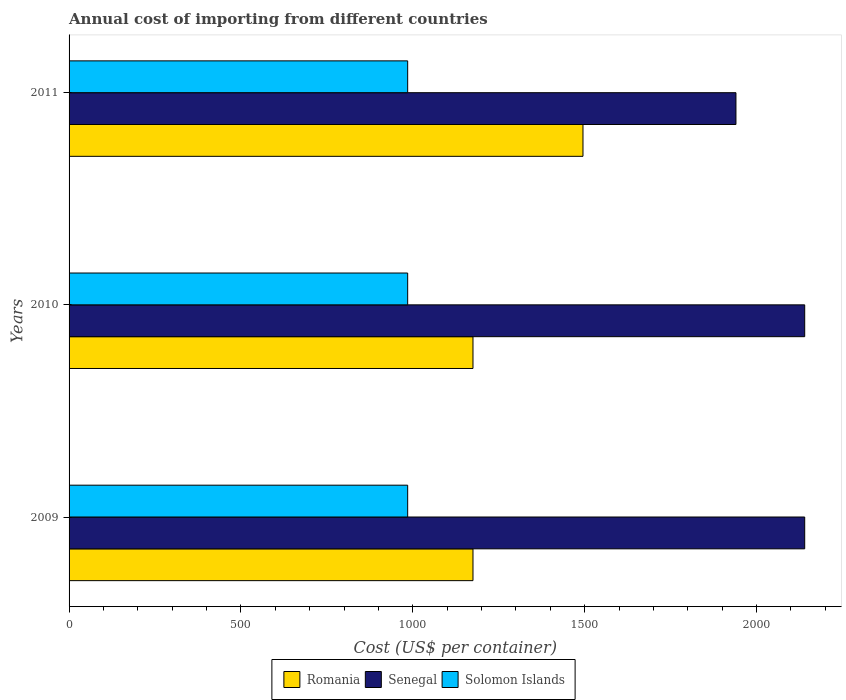How many different coloured bars are there?
Offer a very short reply. 3. Are the number of bars per tick equal to the number of legend labels?
Provide a succinct answer. Yes. How many bars are there on the 1st tick from the top?
Your answer should be very brief. 3. What is the label of the 3rd group of bars from the top?
Provide a short and direct response. 2009. In how many cases, is the number of bars for a given year not equal to the number of legend labels?
Make the answer very short. 0. What is the total annual cost of importing in Solomon Islands in 2009?
Provide a succinct answer. 985. Across all years, what is the maximum total annual cost of importing in Romania?
Your answer should be compact. 1495. Across all years, what is the minimum total annual cost of importing in Solomon Islands?
Your answer should be very brief. 985. In which year was the total annual cost of importing in Senegal maximum?
Ensure brevity in your answer.  2009. In which year was the total annual cost of importing in Romania minimum?
Your answer should be compact. 2009. What is the total total annual cost of importing in Romania in the graph?
Offer a terse response. 3845. What is the difference between the total annual cost of importing in Solomon Islands in 2010 and that in 2011?
Your answer should be compact. 0. What is the difference between the total annual cost of importing in Senegal in 2010 and the total annual cost of importing in Romania in 2009?
Your answer should be very brief. 965. What is the average total annual cost of importing in Romania per year?
Your answer should be compact. 1281.67. In the year 2009, what is the difference between the total annual cost of importing in Senegal and total annual cost of importing in Romania?
Provide a succinct answer. 965. In how many years, is the total annual cost of importing in Solomon Islands greater than 1800 US$?
Offer a very short reply. 0. Is the sum of the total annual cost of importing in Senegal in 2009 and 2011 greater than the maximum total annual cost of importing in Solomon Islands across all years?
Your answer should be compact. Yes. What does the 1st bar from the top in 2009 represents?
Offer a very short reply. Solomon Islands. What does the 2nd bar from the bottom in 2010 represents?
Ensure brevity in your answer.  Senegal. Is it the case that in every year, the sum of the total annual cost of importing in Solomon Islands and total annual cost of importing in Romania is greater than the total annual cost of importing in Senegal?
Provide a succinct answer. Yes. Are all the bars in the graph horizontal?
Ensure brevity in your answer.  Yes. How many years are there in the graph?
Your answer should be compact. 3. What is the difference between two consecutive major ticks on the X-axis?
Your answer should be compact. 500. Does the graph contain any zero values?
Your response must be concise. No. Where does the legend appear in the graph?
Your response must be concise. Bottom center. How many legend labels are there?
Keep it short and to the point. 3. How are the legend labels stacked?
Your answer should be very brief. Horizontal. What is the title of the graph?
Give a very brief answer. Annual cost of importing from different countries. What is the label or title of the X-axis?
Offer a terse response. Cost (US$ per container). What is the Cost (US$ per container) of Romania in 2009?
Keep it short and to the point. 1175. What is the Cost (US$ per container) in Senegal in 2009?
Provide a succinct answer. 2140. What is the Cost (US$ per container) in Solomon Islands in 2009?
Ensure brevity in your answer.  985. What is the Cost (US$ per container) of Romania in 2010?
Keep it short and to the point. 1175. What is the Cost (US$ per container) of Senegal in 2010?
Your answer should be compact. 2140. What is the Cost (US$ per container) in Solomon Islands in 2010?
Your response must be concise. 985. What is the Cost (US$ per container) of Romania in 2011?
Offer a very short reply. 1495. What is the Cost (US$ per container) of Senegal in 2011?
Your response must be concise. 1940. What is the Cost (US$ per container) in Solomon Islands in 2011?
Provide a short and direct response. 985. Across all years, what is the maximum Cost (US$ per container) of Romania?
Offer a very short reply. 1495. Across all years, what is the maximum Cost (US$ per container) in Senegal?
Your response must be concise. 2140. Across all years, what is the maximum Cost (US$ per container) in Solomon Islands?
Offer a terse response. 985. Across all years, what is the minimum Cost (US$ per container) of Romania?
Offer a very short reply. 1175. Across all years, what is the minimum Cost (US$ per container) in Senegal?
Make the answer very short. 1940. Across all years, what is the minimum Cost (US$ per container) in Solomon Islands?
Provide a short and direct response. 985. What is the total Cost (US$ per container) of Romania in the graph?
Provide a succinct answer. 3845. What is the total Cost (US$ per container) of Senegal in the graph?
Offer a very short reply. 6220. What is the total Cost (US$ per container) of Solomon Islands in the graph?
Offer a very short reply. 2955. What is the difference between the Cost (US$ per container) of Solomon Islands in 2009 and that in 2010?
Provide a succinct answer. 0. What is the difference between the Cost (US$ per container) of Romania in 2009 and that in 2011?
Ensure brevity in your answer.  -320. What is the difference between the Cost (US$ per container) of Romania in 2010 and that in 2011?
Provide a short and direct response. -320. What is the difference between the Cost (US$ per container) of Solomon Islands in 2010 and that in 2011?
Offer a terse response. 0. What is the difference between the Cost (US$ per container) in Romania in 2009 and the Cost (US$ per container) in Senegal in 2010?
Your answer should be very brief. -965. What is the difference between the Cost (US$ per container) of Romania in 2009 and the Cost (US$ per container) of Solomon Islands in 2010?
Your answer should be very brief. 190. What is the difference between the Cost (US$ per container) in Senegal in 2009 and the Cost (US$ per container) in Solomon Islands in 2010?
Provide a succinct answer. 1155. What is the difference between the Cost (US$ per container) of Romania in 2009 and the Cost (US$ per container) of Senegal in 2011?
Offer a terse response. -765. What is the difference between the Cost (US$ per container) of Romania in 2009 and the Cost (US$ per container) of Solomon Islands in 2011?
Offer a very short reply. 190. What is the difference between the Cost (US$ per container) of Senegal in 2009 and the Cost (US$ per container) of Solomon Islands in 2011?
Your answer should be compact. 1155. What is the difference between the Cost (US$ per container) of Romania in 2010 and the Cost (US$ per container) of Senegal in 2011?
Offer a terse response. -765. What is the difference between the Cost (US$ per container) in Romania in 2010 and the Cost (US$ per container) in Solomon Islands in 2011?
Your answer should be compact. 190. What is the difference between the Cost (US$ per container) of Senegal in 2010 and the Cost (US$ per container) of Solomon Islands in 2011?
Offer a very short reply. 1155. What is the average Cost (US$ per container) in Romania per year?
Give a very brief answer. 1281.67. What is the average Cost (US$ per container) in Senegal per year?
Your answer should be very brief. 2073.33. What is the average Cost (US$ per container) in Solomon Islands per year?
Your answer should be very brief. 985. In the year 2009, what is the difference between the Cost (US$ per container) of Romania and Cost (US$ per container) of Senegal?
Offer a terse response. -965. In the year 2009, what is the difference between the Cost (US$ per container) of Romania and Cost (US$ per container) of Solomon Islands?
Keep it short and to the point. 190. In the year 2009, what is the difference between the Cost (US$ per container) of Senegal and Cost (US$ per container) of Solomon Islands?
Ensure brevity in your answer.  1155. In the year 2010, what is the difference between the Cost (US$ per container) of Romania and Cost (US$ per container) of Senegal?
Make the answer very short. -965. In the year 2010, what is the difference between the Cost (US$ per container) of Romania and Cost (US$ per container) of Solomon Islands?
Offer a very short reply. 190. In the year 2010, what is the difference between the Cost (US$ per container) of Senegal and Cost (US$ per container) of Solomon Islands?
Ensure brevity in your answer.  1155. In the year 2011, what is the difference between the Cost (US$ per container) of Romania and Cost (US$ per container) of Senegal?
Provide a succinct answer. -445. In the year 2011, what is the difference between the Cost (US$ per container) of Romania and Cost (US$ per container) of Solomon Islands?
Your response must be concise. 510. In the year 2011, what is the difference between the Cost (US$ per container) of Senegal and Cost (US$ per container) of Solomon Islands?
Offer a terse response. 955. What is the ratio of the Cost (US$ per container) in Romania in 2009 to that in 2011?
Your answer should be very brief. 0.79. What is the ratio of the Cost (US$ per container) of Senegal in 2009 to that in 2011?
Provide a short and direct response. 1.1. What is the ratio of the Cost (US$ per container) in Romania in 2010 to that in 2011?
Offer a very short reply. 0.79. What is the ratio of the Cost (US$ per container) in Senegal in 2010 to that in 2011?
Offer a very short reply. 1.1. What is the ratio of the Cost (US$ per container) of Solomon Islands in 2010 to that in 2011?
Ensure brevity in your answer.  1. What is the difference between the highest and the second highest Cost (US$ per container) of Romania?
Give a very brief answer. 320. What is the difference between the highest and the second highest Cost (US$ per container) of Senegal?
Give a very brief answer. 0. What is the difference between the highest and the lowest Cost (US$ per container) of Romania?
Keep it short and to the point. 320. 